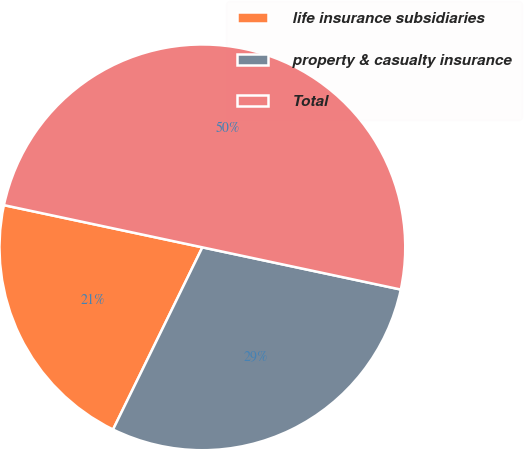<chart> <loc_0><loc_0><loc_500><loc_500><pie_chart><fcel>life insurance subsidiaries<fcel>property & casualty insurance<fcel>Total<nl><fcel>21.08%<fcel>28.92%<fcel>50.0%<nl></chart> 